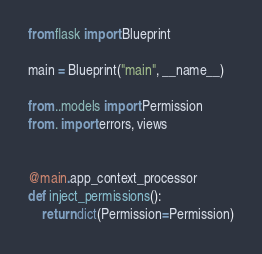<code> <loc_0><loc_0><loc_500><loc_500><_Python_>from flask import Blueprint

main = Blueprint("main", __name__)

from ..models import Permission
from . import errors, views


@main.app_context_processor
def inject_permissions():
    return dict(Permission=Permission)
</code> 